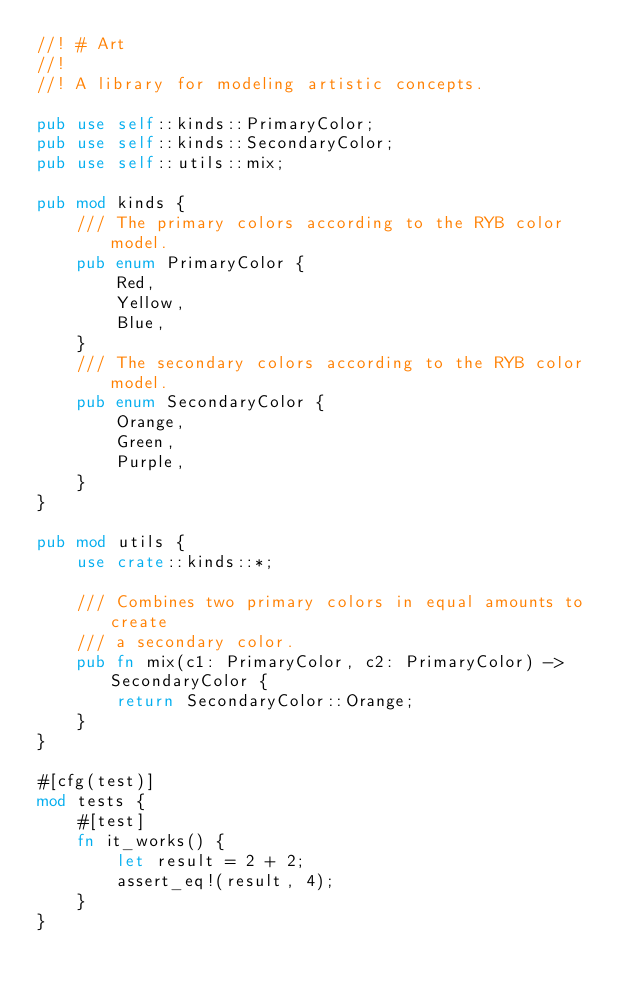Convert code to text. <code><loc_0><loc_0><loc_500><loc_500><_Rust_>//! # Art
//! 
//! A library for modeling artistic concepts.

pub use self::kinds::PrimaryColor;
pub use self::kinds::SecondaryColor;
pub use self::utils::mix;

pub mod kinds {
    /// The primary colors according to the RYB color model.
    pub enum PrimaryColor {
        Red,
        Yellow,
        Blue,
    }
    /// The secondary colors according to the RYB color model.
    pub enum SecondaryColor {
        Orange,
        Green,
        Purple,
    }
}

pub mod utils {
    use crate::kinds::*;

    /// Combines two primary colors in equal amounts to create
    /// a secondary color.
    pub fn mix(c1: PrimaryColor, c2: PrimaryColor) -> SecondaryColor {
        return SecondaryColor::Orange;
    }
}

#[cfg(test)]
mod tests {
    #[test]
    fn it_works() {
        let result = 2 + 2;
        assert_eq!(result, 4);
    }
}
</code> 